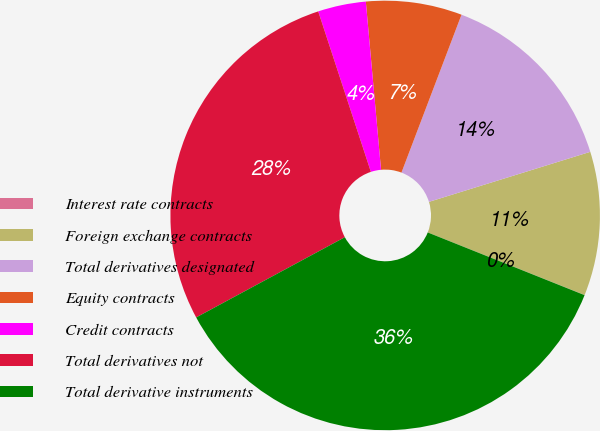Convert chart to OTSL. <chart><loc_0><loc_0><loc_500><loc_500><pie_chart><fcel>Interest rate contracts<fcel>Foreign exchange contracts<fcel>Total derivatives designated<fcel>Equity contracts<fcel>Credit contracts<fcel>Total derivatives not<fcel>Total derivative instruments<nl><fcel>0.01%<fcel>10.83%<fcel>14.43%<fcel>7.22%<fcel>3.61%<fcel>27.83%<fcel>36.07%<nl></chart> 